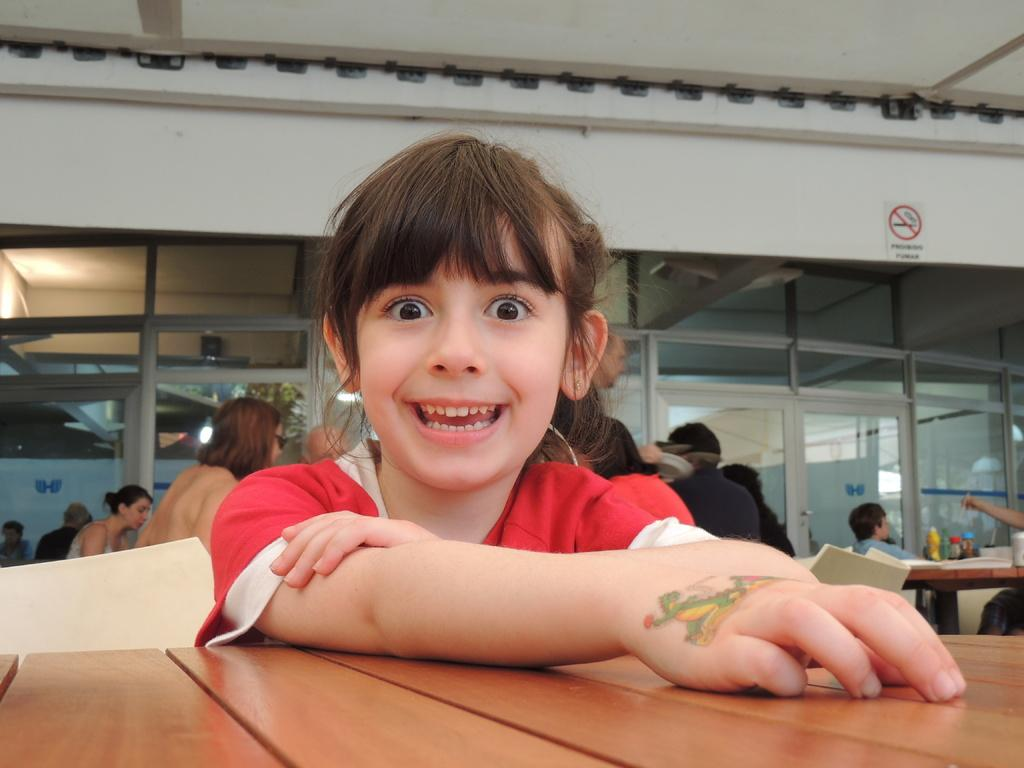What is the girl in the image doing? The girl is seated in the image. What is the girl's expression in the image? The girl is smiling in the image. Are there other people in the image? Yes, there are people seated on chairs in the image. What is the primary object in the image that people are gathered around? There is a table in the image that people are gathered around. What type of road can be seen in the image? There is no road visible in the image. How does the heat affect the girl in the image? The image does not provide any information about the temperature or heat, so we cannot determine its effect on the girl. 